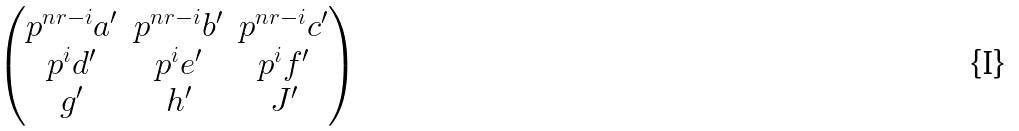Convert formula to latex. <formula><loc_0><loc_0><loc_500><loc_500>\begin{pmatrix} p ^ { n r - i } a ^ { \prime } & p ^ { n r - i } b ^ { \prime } & p ^ { n r - i } c ^ { \prime } \\ p ^ { i } d ^ { \prime } & p ^ { i } e ^ { \prime } & p ^ { i } f ^ { \prime } \\ g ^ { \prime } & h ^ { \prime } & J ^ { \prime } \end{pmatrix}</formula> 